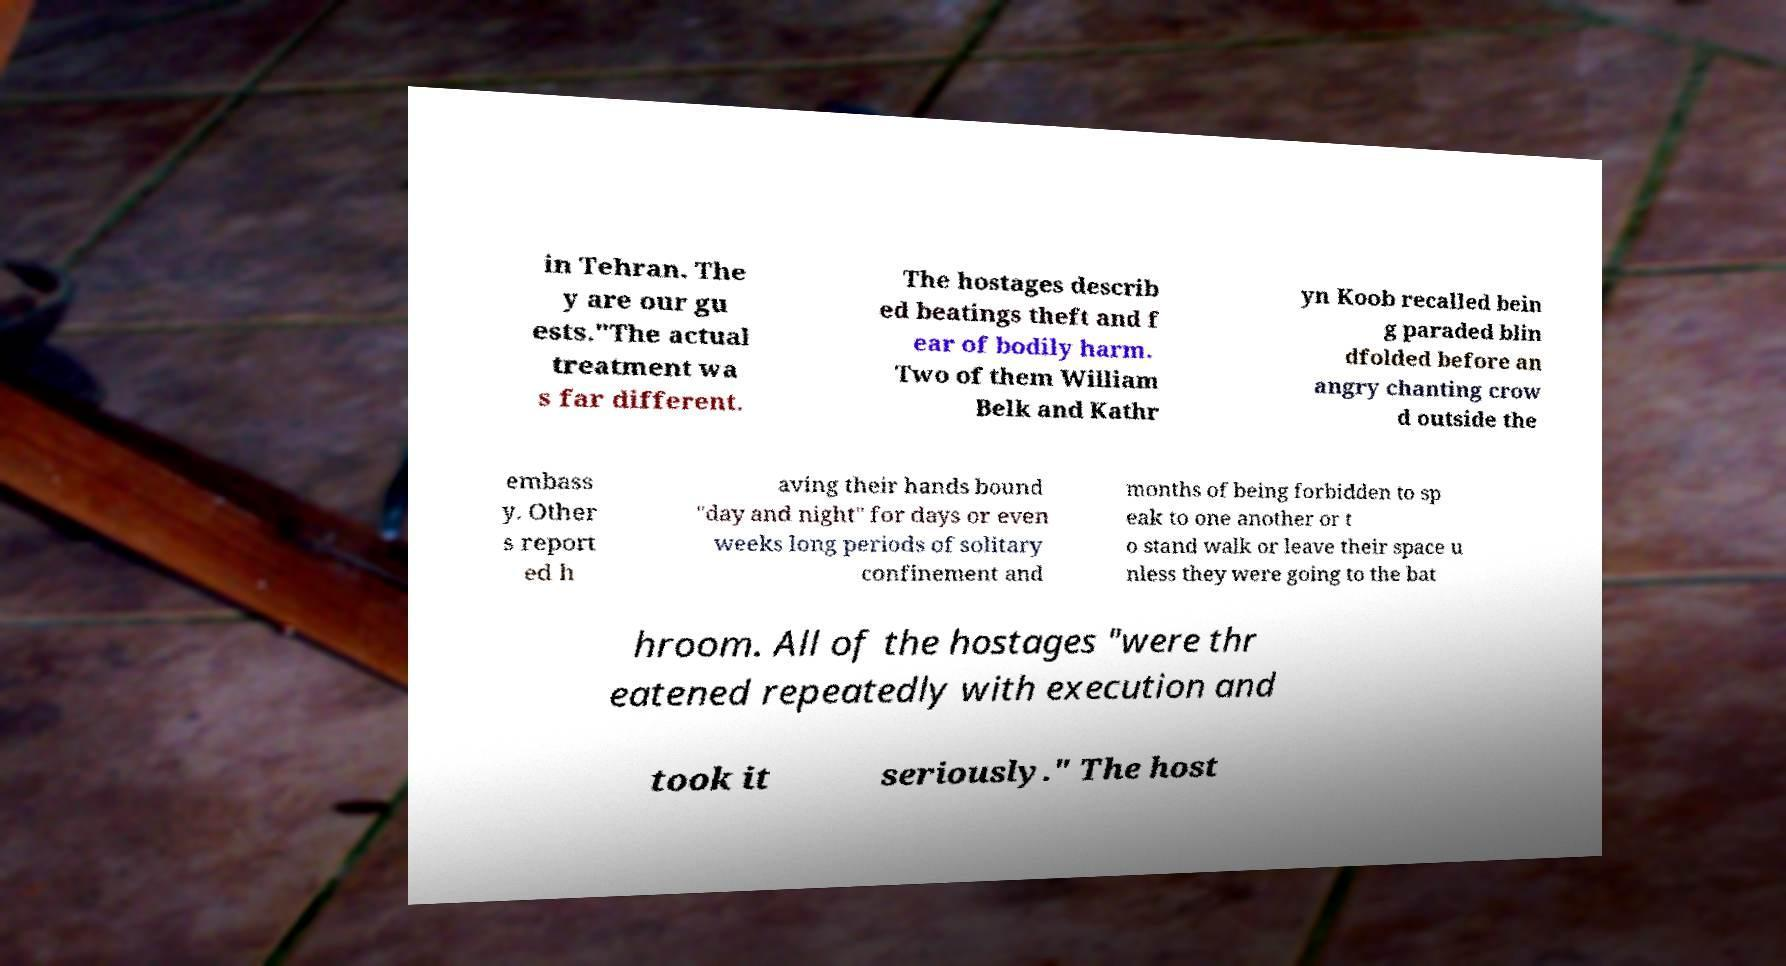For documentation purposes, I need the text within this image transcribed. Could you provide that? in Tehran. The y are our gu ests."The actual treatment wa s far different. The hostages describ ed beatings theft and f ear of bodily harm. Two of them William Belk and Kathr yn Koob recalled bein g paraded blin dfolded before an angry chanting crow d outside the embass y. Other s report ed h aving their hands bound "day and night" for days or even weeks long periods of solitary confinement and months of being forbidden to sp eak to one another or t o stand walk or leave their space u nless they were going to the bat hroom. All of the hostages "were thr eatened repeatedly with execution and took it seriously." The host 